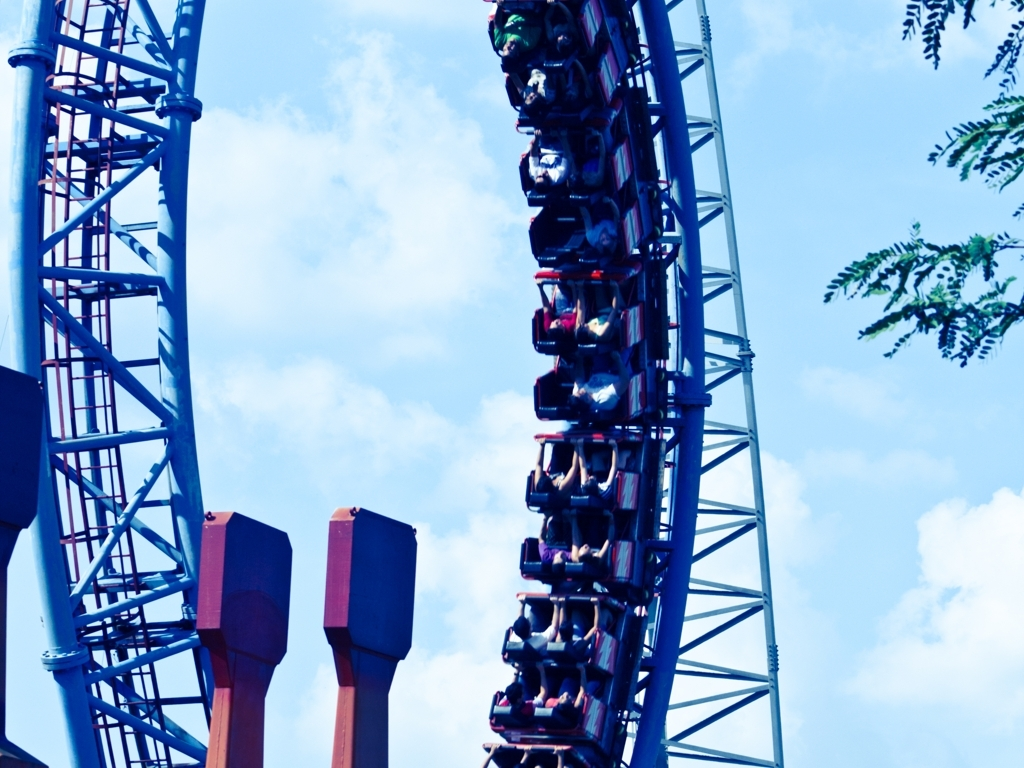What emotions do you think the riders are experiencing? Based on the body language and positions of the riders, they are likely experiencing a mix of thrill, exhilaration, and perhaps a bit of fear. These emotions are common on roller coasters due to the high speeds, sudden drops, and the sensation of defying gravity. Could you describe what part of the roller coaster ride this photo captures? The photo captures a moment where the roller coaster is in a steep descent or possibly an inversion, indicated by the angle of the coaster and the riders' hair and arms that appear to be lifted by gravity and force. 